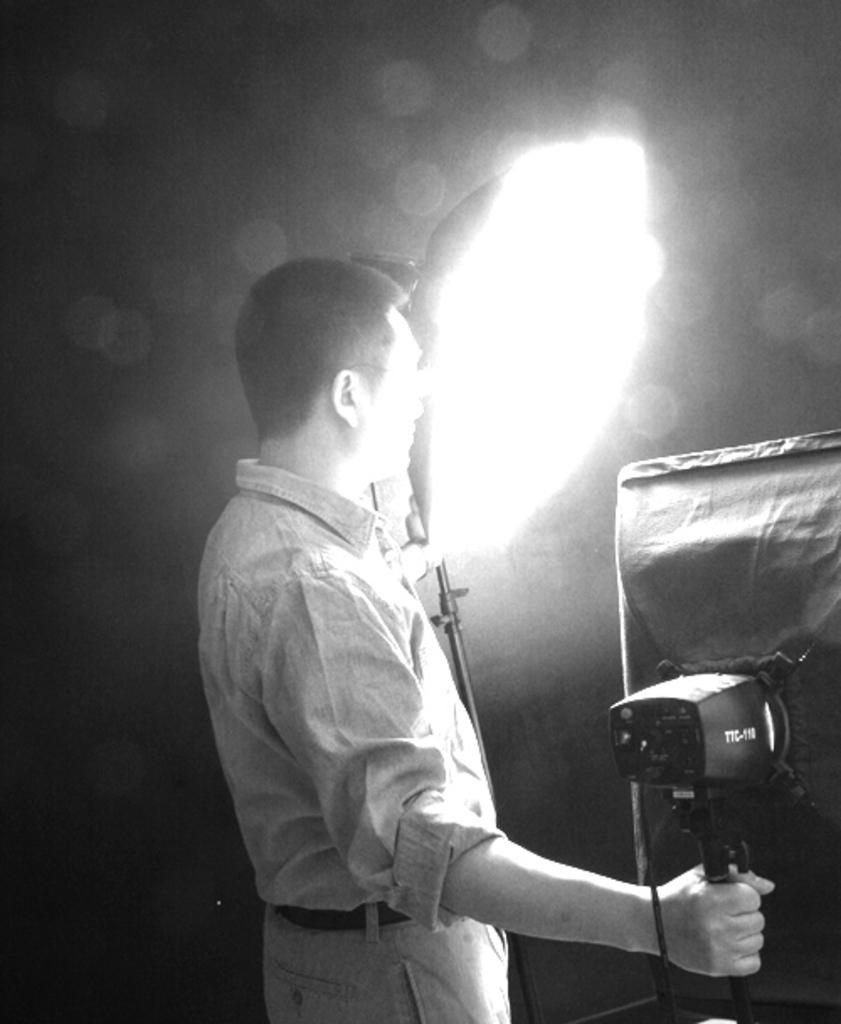What is the main subject of the image? There is a person in the image. What is the person doing in the image? The person is standing and holding two flashlight stands and an umbrella. What is the color scheme of the image? The image is in black and white. white. How many dogs are visible in the image? There are no dogs present in the image. What is the price of the umbrella in the image? The image does not provide information about the price of the umbrella. 